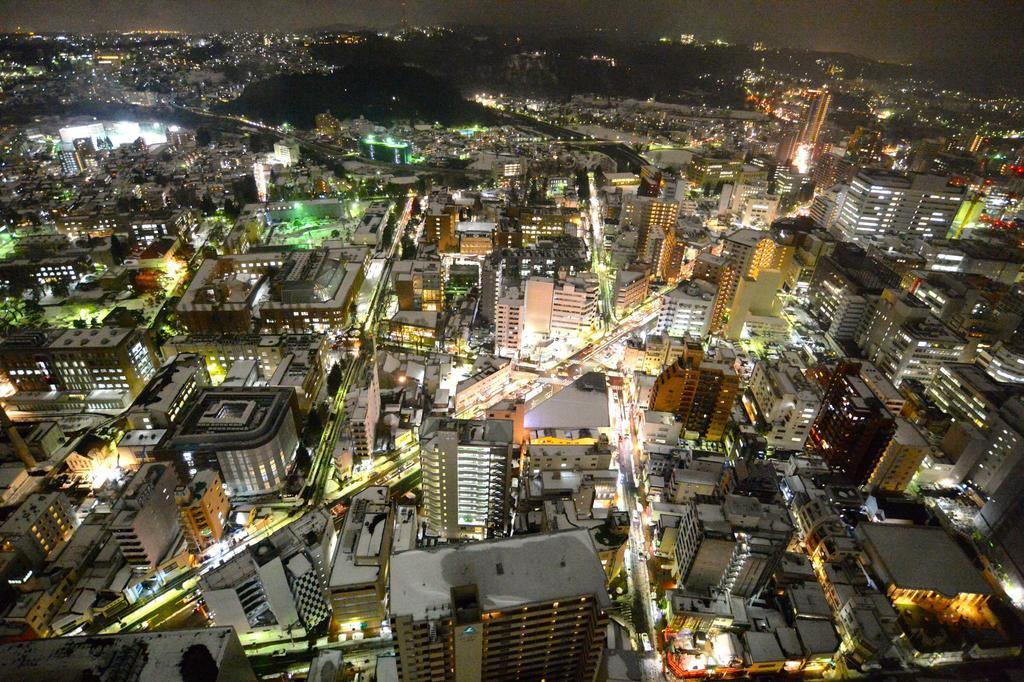What type of view is shown in the image? The image is an aerial view of a city. What types of structures can be seen in the city? There are large buildings and houses in the city. How are people and goods transported within the city? There are roads in the city, and vehicles can be seen traveling on them. What time of day does the image appear to be captured? The image appears to be captured at night. night. What type of jeans is the son wearing in the image? There is no son or jeans present in the image; it is an aerial view of a city at night. What government policies are being implemented in the image? The image does not depict any government policies or actions; it is a view of a city at night. 